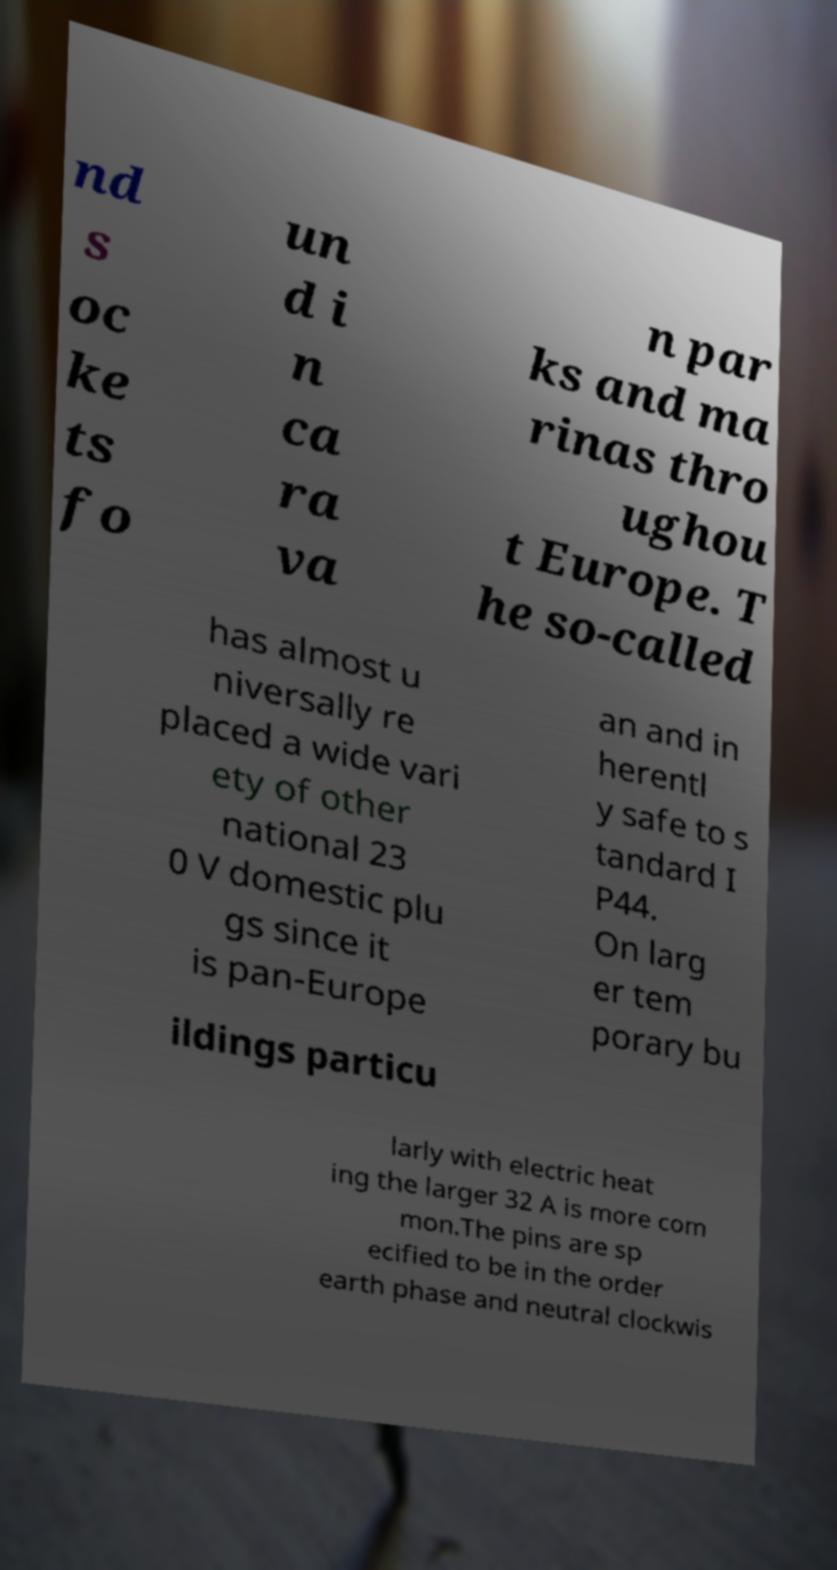Could you assist in decoding the text presented in this image and type it out clearly? nd s oc ke ts fo un d i n ca ra va n par ks and ma rinas thro ughou t Europe. T he so-called has almost u niversally re placed a wide vari ety of other national 23 0 V domestic plu gs since it is pan-Europe an and in herentl y safe to s tandard I P44. On larg er tem porary bu ildings particu larly with electric heat ing the larger 32 A is more com mon.The pins are sp ecified to be in the order earth phase and neutral clockwis 